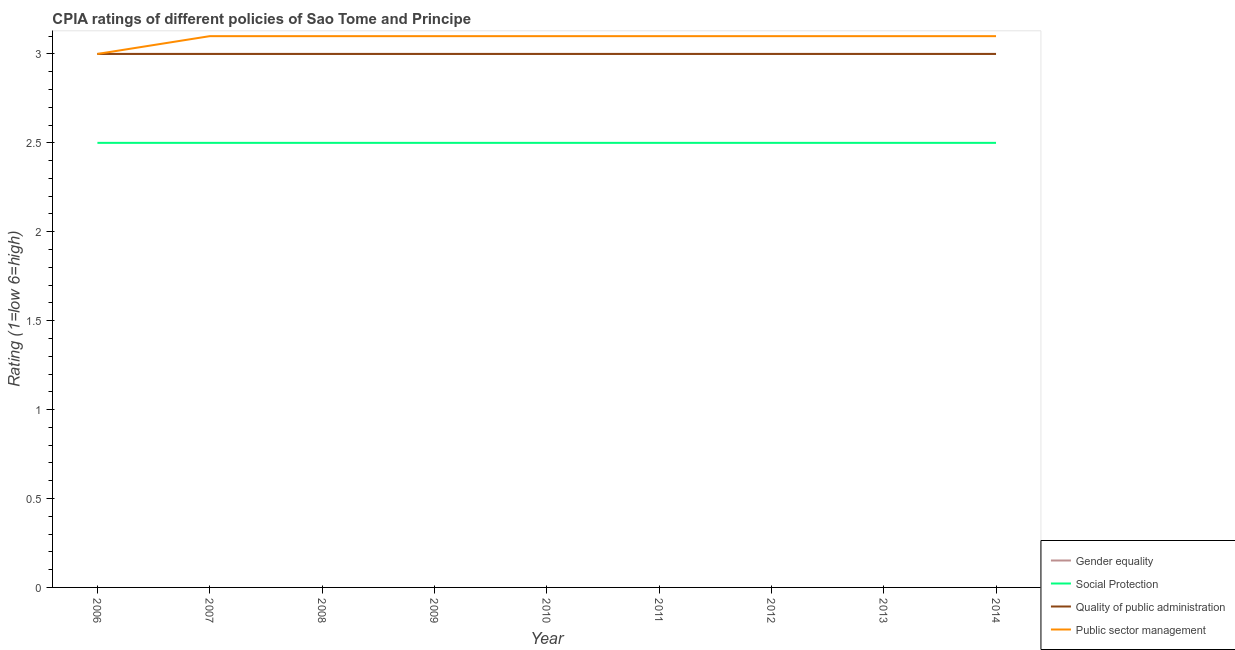How many different coloured lines are there?
Provide a succinct answer. 4. Does the line corresponding to cpia rating of quality of public administration intersect with the line corresponding to cpia rating of gender equality?
Keep it short and to the point. Yes. Is the number of lines equal to the number of legend labels?
Ensure brevity in your answer.  Yes. What is the cpia rating of gender equality in 2014?
Offer a terse response. 3. Across all years, what is the minimum cpia rating of gender equality?
Keep it short and to the point. 3. In which year was the cpia rating of gender equality maximum?
Keep it short and to the point. 2006. In which year was the cpia rating of public sector management minimum?
Offer a terse response. 2006. What is the total cpia rating of gender equality in the graph?
Keep it short and to the point. 27. What is the difference between the cpia rating of public sector management in 2009 and that in 2011?
Offer a terse response. 0. What is the difference between the cpia rating of social protection in 2014 and the cpia rating of public sector management in 2007?
Keep it short and to the point. -0.6. In the year 2012, what is the difference between the cpia rating of public sector management and cpia rating of gender equality?
Provide a succinct answer. 0.1. In how many years, is the cpia rating of social protection greater than 1.5?
Ensure brevity in your answer.  9. What is the ratio of the cpia rating of quality of public administration in 2009 to that in 2012?
Your answer should be compact. 1. What is the difference between the highest and the lowest cpia rating of social protection?
Make the answer very short. 0. In how many years, is the cpia rating of social protection greater than the average cpia rating of social protection taken over all years?
Provide a succinct answer. 0. Is the sum of the cpia rating of social protection in 2012 and 2013 greater than the maximum cpia rating of public sector management across all years?
Your answer should be compact. Yes. Is it the case that in every year, the sum of the cpia rating of gender equality and cpia rating of social protection is greater than the cpia rating of quality of public administration?
Provide a short and direct response. Yes. Is the cpia rating of gender equality strictly greater than the cpia rating of social protection over the years?
Give a very brief answer. Yes. Is the cpia rating of social protection strictly less than the cpia rating of gender equality over the years?
Provide a succinct answer. Yes. What is the difference between two consecutive major ticks on the Y-axis?
Offer a terse response. 0.5. Does the graph contain grids?
Your response must be concise. No. Where does the legend appear in the graph?
Keep it short and to the point. Bottom right. How are the legend labels stacked?
Ensure brevity in your answer.  Vertical. What is the title of the graph?
Offer a very short reply. CPIA ratings of different policies of Sao Tome and Principe. What is the Rating (1=low 6=high) of Gender equality in 2006?
Your answer should be compact. 3. What is the Rating (1=low 6=high) in Social Protection in 2006?
Your answer should be compact. 2.5. What is the Rating (1=low 6=high) in Public sector management in 2006?
Ensure brevity in your answer.  3. What is the Rating (1=low 6=high) in Public sector management in 2007?
Ensure brevity in your answer.  3.1. What is the Rating (1=low 6=high) in Gender equality in 2008?
Offer a very short reply. 3. What is the Rating (1=low 6=high) in Social Protection in 2008?
Provide a short and direct response. 2.5. What is the Rating (1=low 6=high) in Public sector management in 2008?
Your answer should be compact. 3.1. What is the Rating (1=low 6=high) of Quality of public administration in 2009?
Keep it short and to the point. 3. What is the Rating (1=low 6=high) in Public sector management in 2009?
Provide a short and direct response. 3.1. What is the Rating (1=low 6=high) in Quality of public administration in 2010?
Your response must be concise. 3. What is the Rating (1=low 6=high) of Public sector management in 2010?
Offer a very short reply. 3.1. What is the Rating (1=low 6=high) of Social Protection in 2011?
Keep it short and to the point. 2.5. What is the Rating (1=low 6=high) in Quality of public administration in 2011?
Ensure brevity in your answer.  3. What is the Rating (1=low 6=high) of Public sector management in 2011?
Give a very brief answer. 3.1. What is the Rating (1=low 6=high) of Quality of public administration in 2012?
Your answer should be compact. 3. What is the Rating (1=low 6=high) in Gender equality in 2013?
Offer a terse response. 3. What is the Rating (1=low 6=high) in Social Protection in 2013?
Your answer should be compact. 2.5. What is the Rating (1=low 6=high) of Public sector management in 2013?
Keep it short and to the point. 3.1. What is the Rating (1=low 6=high) in Gender equality in 2014?
Make the answer very short. 3. What is the Rating (1=low 6=high) in Social Protection in 2014?
Your answer should be compact. 2.5. Across all years, what is the maximum Rating (1=low 6=high) of Gender equality?
Ensure brevity in your answer.  3. Across all years, what is the minimum Rating (1=low 6=high) in Gender equality?
Ensure brevity in your answer.  3. Across all years, what is the minimum Rating (1=low 6=high) in Social Protection?
Keep it short and to the point. 2.5. Across all years, what is the minimum Rating (1=low 6=high) of Quality of public administration?
Provide a succinct answer. 3. Across all years, what is the minimum Rating (1=low 6=high) in Public sector management?
Offer a terse response. 3. What is the total Rating (1=low 6=high) of Gender equality in the graph?
Your response must be concise. 27. What is the total Rating (1=low 6=high) of Quality of public administration in the graph?
Make the answer very short. 27. What is the total Rating (1=low 6=high) of Public sector management in the graph?
Keep it short and to the point. 27.8. What is the difference between the Rating (1=low 6=high) in Social Protection in 2006 and that in 2007?
Your response must be concise. 0. What is the difference between the Rating (1=low 6=high) in Gender equality in 2006 and that in 2009?
Provide a short and direct response. 0. What is the difference between the Rating (1=low 6=high) of Social Protection in 2006 and that in 2009?
Your response must be concise. 0. What is the difference between the Rating (1=low 6=high) in Public sector management in 2006 and that in 2009?
Provide a succinct answer. -0.1. What is the difference between the Rating (1=low 6=high) in Gender equality in 2006 and that in 2010?
Offer a terse response. 0. What is the difference between the Rating (1=low 6=high) in Social Protection in 2006 and that in 2010?
Offer a terse response. 0. What is the difference between the Rating (1=low 6=high) in Quality of public administration in 2006 and that in 2010?
Provide a succinct answer. 0. What is the difference between the Rating (1=low 6=high) in Public sector management in 2006 and that in 2010?
Provide a short and direct response. -0.1. What is the difference between the Rating (1=low 6=high) of Social Protection in 2006 and that in 2011?
Keep it short and to the point. 0. What is the difference between the Rating (1=low 6=high) of Gender equality in 2006 and that in 2012?
Your response must be concise. 0. What is the difference between the Rating (1=low 6=high) in Social Protection in 2006 and that in 2012?
Ensure brevity in your answer.  0. What is the difference between the Rating (1=low 6=high) of Social Protection in 2006 and that in 2013?
Offer a terse response. 0. What is the difference between the Rating (1=low 6=high) in Quality of public administration in 2006 and that in 2013?
Give a very brief answer. 0. What is the difference between the Rating (1=low 6=high) of Social Protection in 2006 and that in 2014?
Provide a succinct answer. 0. What is the difference between the Rating (1=low 6=high) of Quality of public administration in 2006 and that in 2014?
Offer a terse response. 0. What is the difference between the Rating (1=low 6=high) in Public sector management in 2007 and that in 2008?
Your response must be concise. 0. What is the difference between the Rating (1=low 6=high) of Quality of public administration in 2007 and that in 2009?
Your answer should be compact. 0. What is the difference between the Rating (1=low 6=high) in Public sector management in 2007 and that in 2009?
Make the answer very short. 0. What is the difference between the Rating (1=low 6=high) of Quality of public administration in 2007 and that in 2010?
Ensure brevity in your answer.  0. What is the difference between the Rating (1=low 6=high) in Public sector management in 2007 and that in 2010?
Provide a succinct answer. 0. What is the difference between the Rating (1=low 6=high) in Social Protection in 2007 and that in 2011?
Provide a short and direct response. 0. What is the difference between the Rating (1=low 6=high) of Public sector management in 2007 and that in 2011?
Your response must be concise. 0. What is the difference between the Rating (1=low 6=high) in Social Protection in 2007 and that in 2012?
Offer a terse response. 0. What is the difference between the Rating (1=low 6=high) of Quality of public administration in 2007 and that in 2012?
Your answer should be compact. 0. What is the difference between the Rating (1=low 6=high) of Public sector management in 2007 and that in 2012?
Offer a very short reply. 0. What is the difference between the Rating (1=low 6=high) in Gender equality in 2007 and that in 2013?
Provide a succinct answer. 0. What is the difference between the Rating (1=low 6=high) of Social Protection in 2007 and that in 2013?
Make the answer very short. 0. What is the difference between the Rating (1=low 6=high) in Quality of public administration in 2007 and that in 2013?
Your response must be concise. 0. What is the difference between the Rating (1=low 6=high) of Gender equality in 2007 and that in 2014?
Offer a terse response. 0. What is the difference between the Rating (1=low 6=high) in Social Protection in 2007 and that in 2014?
Your answer should be very brief. 0. What is the difference between the Rating (1=low 6=high) of Public sector management in 2007 and that in 2014?
Provide a succinct answer. 0. What is the difference between the Rating (1=low 6=high) of Gender equality in 2008 and that in 2009?
Provide a short and direct response. 0. What is the difference between the Rating (1=low 6=high) of Public sector management in 2008 and that in 2009?
Provide a succinct answer. 0. What is the difference between the Rating (1=low 6=high) in Social Protection in 2008 and that in 2010?
Your answer should be compact. 0. What is the difference between the Rating (1=low 6=high) of Gender equality in 2008 and that in 2011?
Ensure brevity in your answer.  0. What is the difference between the Rating (1=low 6=high) of Social Protection in 2008 and that in 2011?
Your answer should be very brief. 0. What is the difference between the Rating (1=low 6=high) of Social Protection in 2008 and that in 2012?
Offer a very short reply. 0. What is the difference between the Rating (1=low 6=high) in Public sector management in 2008 and that in 2012?
Give a very brief answer. 0. What is the difference between the Rating (1=low 6=high) in Social Protection in 2008 and that in 2013?
Provide a short and direct response. 0. What is the difference between the Rating (1=low 6=high) of Quality of public administration in 2008 and that in 2013?
Your answer should be compact. 0. What is the difference between the Rating (1=low 6=high) of Public sector management in 2008 and that in 2013?
Give a very brief answer. 0. What is the difference between the Rating (1=low 6=high) of Public sector management in 2008 and that in 2014?
Provide a succinct answer. 0. What is the difference between the Rating (1=low 6=high) in Gender equality in 2009 and that in 2010?
Offer a very short reply. 0. What is the difference between the Rating (1=low 6=high) in Social Protection in 2009 and that in 2010?
Your answer should be very brief. 0. What is the difference between the Rating (1=low 6=high) of Public sector management in 2009 and that in 2011?
Ensure brevity in your answer.  0. What is the difference between the Rating (1=low 6=high) of Gender equality in 2009 and that in 2012?
Provide a succinct answer. 0. What is the difference between the Rating (1=low 6=high) of Public sector management in 2009 and that in 2013?
Offer a very short reply. 0. What is the difference between the Rating (1=low 6=high) in Gender equality in 2010 and that in 2011?
Your answer should be very brief. 0. What is the difference between the Rating (1=low 6=high) in Quality of public administration in 2010 and that in 2011?
Offer a very short reply. 0. What is the difference between the Rating (1=low 6=high) of Public sector management in 2010 and that in 2011?
Your response must be concise. 0. What is the difference between the Rating (1=low 6=high) in Gender equality in 2010 and that in 2012?
Your answer should be very brief. 0. What is the difference between the Rating (1=low 6=high) of Quality of public administration in 2010 and that in 2012?
Offer a terse response. 0. What is the difference between the Rating (1=low 6=high) in Public sector management in 2010 and that in 2012?
Your answer should be very brief. 0. What is the difference between the Rating (1=low 6=high) in Social Protection in 2010 and that in 2013?
Give a very brief answer. 0. What is the difference between the Rating (1=low 6=high) in Quality of public administration in 2010 and that in 2013?
Provide a succinct answer. 0. What is the difference between the Rating (1=low 6=high) in Gender equality in 2010 and that in 2014?
Your answer should be compact. 0. What is the difference between the Rating (1=low 6=high) in Quality of public administration in 2010 and that in 2014?
Give a very brief answer. 0. What is the difference between the Rating (1=low 6=high) of Public sector management in 2010 and that in 2014?
Offer a terse response. 0. What is the difference between the Rating (1=low 6=high) of Social Protection in 2011 and that in 2012?
Provide a succinct answer. 0. What is the difference between the Rating (1=low 6=high) of Gender equality in 2011 and that in 2013?
Provide a succinct answer. 0. What is the difference between the Rating (1=low 6=high) of Public sector management in 2011 and that in 2013?
Offer a terse response. 0. What is the difference between the Rating (1=low 6=high) in Social Protection in 2011 and that in 2014?
Offer a terse response. 0. What is the difference between the Rating (1=low 6=high) of Gender equality in 2012 and that in 2013?
Provide a succinct answer. 0. What is the difference between the Rating (1=low 6=high) of Social Protection in 2012 and that in 2013?
Give a very brief answer. 0. What is the difference between the Rating (1=low 6=high) of Public sector management in 2012 and that in 2013?
Provide a short and direct response. 0. What is the difference between the Rating (1=low 6=high) of Gender equality in 2012 and that in 2014?
Keep it short and to the point. 0. What is the difference between the Rating (1=low 6=high) in Public sector management in 2012 and that in 2014?
Provide a succinct answer. 0. What is the difference between the Rating (1=low 6=high) in Social Protection in 2013 and that in 2014?
Offer a very short reply. 0. What is the difference between the Rating (1=low 6=high) in Quality of public administration in 2013 and that in 2014?
Ensure brevity in your answer.  0. What is the difference between the Rating (1=low 6=high) of Gender equality in 2006 and the Rating (1=low 6=high) of Social Protection in 2007?
Offer a terse response. 0.5. What is the difference between the Rating (1=low 6=high) of Social Protection in 2006 and the Rating (1=low 6=high) of Public sector management in 2007?
Give a very brief answer. -0.6. What is the difference between the Rating (1=low 6=high) of Quality of public administration in 2006 and the Rating (1=low 6=high) of Public sector management in 2007?
Keep it short and to the point. -0.1. What is the difference between the Rating (1=low 6=high) of Gender equality in 2006 and the Rating (1=low 6=high) of Public sector management in 2008?
Your answer should be very brief. -0.1. What is the difference between the Rating (1=low 6=high) of Social Protection in 2006 and the Rating (1=low 6=high) of Public sector management in 2008?
Give a very brief answer. -0.6. What is the difference between the Rating (1=low 6=high) in Quality of public administration in 2006 and the Rating (1=low 6=high) in Public sector management in 2008?
Make the answer very short. -0.1. What is the difference between the Rating (1=low 6=high) in Gender equality in 2006 and the Rating (1=low 6=high) in Social Protection in 2009?
Your answer should be compact. 0.5. What is the difference between the Rating (1=low 6=high) of Gender equality in 2006 and the Rating (1=low 6=high) of Quality of public administration in 2009?
Provide a short and direct response. 0. What is the difference between the Rating (1=low 6=high) of Social Protection in 2006 and the Rating (1=low 6=high) of Quality of public administration in 2009?
Make the answer very short. -0.5. What is the difference between the Rating (1=low 6=high) of Gender equality in 2006 and the Rating (1=low 6=high) of Social Protection in 2010?
Give a very brief answer. 0.5. What is the difference between the Rating (1=low 6=high) of Gender equality in 2006 and the Rating (1=low 6=high) of Quality of public administration in 2010?
Keep it short and to the point. 0. What is the difference between the Rating (1=low 6=high) of Gender equality in 2006 and the Rating (1=low 6=high) of Public sector management in 2011?
Offer a very short reply. -0.1. What is the difference between the Rating (1=low 6=high) in Social Protection in 2006 and the Rating (1=low 6=high) in Quality of public administration in 2011?
Your response must be concise. -0.5. What is the difference between the Rating (1=low 6=high) in Gender equality in 2006 and the Rating (1=low 6=high) in Quality of public administration in 2012?
Keep it short and to the point. 0. What is the difference between the Rating (1=low 6=high) of Gender equality in 2006 and the Rating (1=low 6=high) of Public sector management in 2012?
Your answer should be compact. -0.1. What is the difference between the Rating (1=low 6=high) in Social Protection in 2006 and the Rating (1=low 6=high) in Quality of public administration in 2012?
Keep it short and to the point. -0.5. What is the difference between the Rating (1=low 6=high) in Gender equality in 2006 and the Rating (1=low 6=high) in Quality of public administration in 2013?
Keep it short and to the point. 0. What is the difference between the Rating (1=low 6=high) in Social Protection in 2006 and the Rating (1=low 6=high) in Quality of public administration in 2013?
Provide a short and direct response. -0.5. What is the difference between the Rating (1=low 6=high) in Gender equality in 2006 and the Rating (1=low 6=high) in Social Protection in 2014?
Keep it short and to the point. 0.5. What is the difference between the Rating (1=low 6=high) in Gender equality in 2006 and the Rating (1=low 6=high) in Quality of public administration in 2014?
Ensure brevity in your answer.  0. What is the difference between the Rating (1=low 6=high) of Gender equality in 2006 and the Rating (1=low 6=high) of Public sector management in 2014?
Offer a very short reply. -0.1. What is the difference between the Rating (1=low 6=high) of Social Protection in 2006 and the Rating (1=low 6=high) of Public sector management in 2014?
Keep it short and to the point. -0.6. What is the difference between the Rating (1=low 6=high) in Quality of public administration in 2006 and the Rating (1=low 6=high) in Public sector management in 2014?
Keep it short and to the point. -0.1. What is the difference between the Rating (1=low 6=high) in Gender equality in 2007 and the Rating (1=low 6=high) in Social Protection in 2008?
Your answer should be very brief. 0.5. What is the difference between the Rating (1=low 6=high) in Gender equality in 2007 and the Rating (1=low 6=high) in Quality of public administration in 2008?
Your answer should be compact. 0. What is the difference between the Rating (1=low 6=high) in Gender equality in 2007 and the Rating (1=low 6=high) in Public sector management in 2008?
Ensure brevity in your answer.  -0.1. What is the difference between the Rating (1=low 6=high) in Social Protection in 2007 and the Rating (1=low 6=high) in Public sector management in 2008?
Offer a very short reply. -0.6. What is the difference between the Rating (1=low 6=high) in Quality of public administration in 2007 and the Rating (1=low 6=high) in Public sector management in 2008?
Your response must be concise. -0.1. What is the difference between the Rating (1=low 6=high) in Social Protection in 2007 and the Rating (1=low 6=high) in Public sector management in 2009?
Give a very brief answer. -0.6. What is the difference between the Rating (1=low 6=high) in Gender equality in 2007 and the Rating (1=low 6=high) in Social Protection in 2010?
Your answer should be compact. 0.5. What is the difference between the Rating (1=low 6=high) of Gender equality in 2007 and the Rating (1=low 6=high) of Public sector management in 2010?
Offer a terse response. -0.1. What is the difference between the Rating (1=low 6=high) in Quality of public administration in 2007 and the Rating (1=low 6=high) in Public sector management in 2010?
Make the answer very short. -0.1. What is the difference between the Rating (1=low 6=high) of Social Protection in 2007 and the Rating (1=low 6=high) of Quality of public administration in 2011?
Keep it short and to the point. -0.5. What is the difference between the Rating (1=low 6=high) in Gender equality in 2007 and the Rating (1=low 6=high) in Public sector management in 2012?
Give a very brief answer. -0.1. What is the difference between the Rating (1=low 6=high) in Social Protection in 2007 and the Rating (1=low 6=high) in Quality of public administration in 2012?
Provide a succinct answer. -0.5. What is the difference between the Rating (1=low 6=high) of Social Protection in 2007 and the Rating (1=low 6=high) of Public sector management in 2012?
Your answer should be very brief. -0.6. What is the difference between the Rating (1=low 6=high) in Quality of public administration in 2007 and the Rating (1=low 6=high) in Public sector management in 2013?
Offer a very short reply. -0.1. What is the difference between the Rating (1=low 6=high) of Gender equality in 2007 and the Rating (1=low 6=high) of Social Protection in 2014?
Your response must be concise. 0.5. What is the difference between the Rating (1=low 6=high) in Social Protection in 2007 and the Rating (1=low 6=high) in Quality of public administration in 2014?
Offer a very short reply. -0.5. What is the difference between the Rating (1=low 6=high) in Social Protection in 2007 and the Rating (1=low 6=high) in Public sector management in 2014?
Make the answer very short. -0.6. What is the difference between the Rating (1=low 6=high) in Gender equality in 2008 and the Rating (1=low 6=high) in Social Protection in 2009?
Your response must be concise. 0.5. What is the difference between the Rating (1=low 6=high) of Gender equality in 2008 and the Rating (1=low 6=high) of Public sector management in 2009?
Your response must be concise. -0.1. What is the difference between the Rating (1=low 6=high) of Gender equality in 2008 and the Rating (1=low 6=high) of Social Protection in 2010?
Offer a terse response. 0.5. What is the difference between the Rating (1=low 6=high) in Gender equality in 2008 and the Rating (1=low 6=high) in Public sector management in 2010?
Give a very brief answer. -0.1. What is the difference between the Rating (1=low 6=high) in Social Protection in 2008 and the Rating (1=low 6=high) in Quality of public administration in 2010?
Ensure brevity in your answer.  -0.5. What is the difference between the Rating (1=low 6=high) in Social Protection in 2008 and the Rating (1=low 6=high) in Public sector management in 2010?
Give a very brief answer. -0.6. What is the difference between the Rating (1=low 6=high) of Gender equality in 2008 and the Rating (1=low 6=high) of Quality of public administration in 2011?
Make the answer very short. 0. What is the difference between the Rating (1=low 6=high) of Social Protection in 2008 and the Rating (1=low 6=high) of Quality of public administration in 2011?
Ensure brevity in your answer.  -0.5. What is the difference between the Rating (1=low 6=high) of Social Protection in 2008 and the Rating (1=low 6=high) of Public sector management in 2011?
Offer a terse response. -0.6. What is the difference between the Rating (1=low 6=high) in Quality of public administration in 2008 and the Rating (1=low 6=high) in Public sector management in 2011?
Your answer should be compact. -0.1. What is the difference between the Rating (1=low 6=high) in Gender equality in 2008 and the Rating (1=low 6=high) in Public sector management in 2012?
Your answer should be compact. -0.1. What is the difference between the Rating (1=low 6=high) in Social Protection in 2008 and the Rating (1=low 6=high) in Public sector management in 2012?
Ensure brevity in your answer.  -0.6. What is the difference between the Rating (1=low 6=high) in Quality of public administration in 2008 and the Rating (1=low 6=high) in Public sector management in 2012?
Your answer should be very brief. -0.1. What is the difference between the Rating (1=low 6=high) of Gender equality in 2008 and the Rating (1=low 6=high) of Social Protection in 2013?
Your response must be concise. 0.5. What is the difference between the Rating (1=low 6=high) in Gender equality in 2008 and the Rating (1=low 6=high) in Quality of public administration in 2013?
Offer a terse response. 0. What is the difference between the Rating (1=low 6=high) of Quality of public administration in 2008 and the Rating (1=low 6=high) of Public sector management in 2013?
Give a very brief answer. -0.1. What is the difference between the Rating (1=low 6=high) of Gender equality in 2008 and the Rating (1=low 6=high) of Social Protection in 2014?
Provide a short and direct response. 0.5. What is the difference between the Rating (1=low 6=high) in Gender equality in 2008 and the Rating (1=low 6=high) in Public sector management in 2014?
Keep it short and to the point. -0.1. What is the difference between the Rating (1=low 6=high) in Quality of public administration in 2008 and the Rating (1=low 6=high) in Public sector management in 2014?
Provide a short and direct response. -0.1. What is the difference between the Rating (1=low 6=high) in Gender equality in 2009 and the Rating (1=low 6=high) in Social Protection in 2010?
Provide a short and direct response. 0.5. What is the difference between the Rating (1=low 6=high) of Social Protection in 2009 and the Rating (1=low 6=high) of Quality of public administration in 2010?
Provide a succinct answer. -0.5. What is the difference between the Rating (1=low 6=high) in Social Protection in 2009 and the Rating (1=low 6=high) in Public sector management in 2010?
Make the answer very short. -0.6. What is the difference between the Rating (1=low 6=high) of Gender equality in 2009 and the Rating (1=low 6=high) of Quality of public administration in 2011?
Offer a terse response. 0. What is the difference between the Rating (1=low 6=high) of Gender equality in 2009 and the Rating (1=low 6=high) of Quality of public administration in 2012?
Ensure brevity in your answer.  0. What is the difference between the Rating (1=low 6=high) in Social Protection in 2009 and the Rating (1=low 6=high) in Quality of public administration in 2012?
Offer a very short reply. -0.5. What is the difference between the Rating (1=low 6=high) in Social Protection in 2009 and the Rating (1=low 6=high) in Public sector management in 2012?
Your response must be concise. -0.6. What is the difference between the Rating (1=low 6=high) of Gender equality in 2009 and the Rating (1=low 6=high) of Social Protection in 2013?
Keep it short and to the point. 0.5. What is the difference between the Rating (1=low 6=high) in Gender equality in 2009 and the Rating (1=low 6=high) in Public sector management in 2013?
Your answer should be compact. -0.1. What is the difference between the Rating (1=low 6=high) in Gender equality in 2009 and the Rating (1=low 6=high) in Social Protection in 2014?
Your answer should be very brief. 0.5. What is the difference between the Rating (1=low 6=high) of Gender equality in 2009 and the Rating (1=low 6=high) of Quality of public administration in 2014?
Provide a short and direct response. 0. What is the difference between the Rating (1=low 6=high) of Gender equality in 2009 and the Rating (1=low 6=high) of Public sector management in 2014?
Provide a short and direct response. -0.1. What is the difference between the Rating (1=low 6=high) of Social Protection in 2009 and the Rating (1=low 6=high) of Quality of public administration in 2014?
Make the answer very short. -0.5. What is the difference between the Rating (1=low 6=high) in Quality of public administration in 2009 and the Rating (1=low 6=high) in Public sector management in 2014?
Provide a short and direct response. -0.1. What is the difference between the Rating (1=low 6=high) in Gender equality in 2010 and the Rating (1=low 6=high) in Social Protection in 2011?
Provide a succinct answer. 0.5. What is the difference between the Rating (1=low 6=high) in Gender equality in 2010 and the Rating (1=low 6=high) in Quality of public administration in 2011?
Make the answer very short. 0. What is the difference between the Rating (1=low 6=high) in Gender equality in 2010 and the Rating (1=low 6=high) in Social Protection in 2012?
Make the answer very short. 0.5. What is the difference between the Rating (1=low 6=high) in Gender equality in 2010 and the Rating (1=low 6=high) in Public sector management in 2012?
Keep it short and to the point. -0.1. What is the difference between the Rating (1=low 6=high) in Gender equality in 2010 and the Rating (1=low 6=high) in Social Protection in 2013?
Make the answer very short. 0.5. What is the difference between the Rating (1=low 6=high) of Social Protection in 2010 and the Rating (1=low 6=high) of Quality of public administration in 2013?
Your response must be concise. -0.5. What is the difference between the Rating (1=low 6=high) of Social Protection in 2010 and the Rating (1=low 6=high) of Public sector management in 2013?
Your response must be concise. -0.6. What is the difference between the Rating (1=low 6=high) in Quality of public administration in 2010 and the Rating (1=low 6=high) in Public sector management in 2013?
Offer a very short reply. -0.1. What is the difference between the Rating (1=low 6=high) in Gender equality in 2010 and the Rating (1=low 6=high) in Quality of public administration in 2014?
Offer a very short reply. 0. What is the difference between the Rating (1=low 6=high) of Social Protection in 2010 and the Rating (1=low 6=high) of Quality of public administration in 2014?
Your answer should be very brief. -0.5. What is the difference between the Rating (1=low 6=high) in Quality of public administration in 2010 and the Rating (1=low 6=high) in Public sector management in 2014?
Provide a succinct answer. -0.1. What is the difference between the Rating (1=low 6=high) of Gender equality in 2011 and the Rating (1=low 6=high) of Quality of public administration in 2012?
Your answer should be very brief. 0. What is the difference between the Rating (1=low 6=high) in Quality of public administration in 2011 and the Rating (1=low 6=high) in Public sector management in 2012?
Make the answer very short. -0.1. What is the difference between the Rating (1=low 6=high) in Gender equality in 2011 and the Rating (1=low 6=high) in Quality of public administration in 2013?
Make the answer very short. 0. What is the difference between the Rating (1=low 6=high) of Gender equality in 2011 and the Rating (1=low 6=high) of Public sector management in 2013?
Offer a very short reply. -0.1. What is the difference between the Rating (1=low 6=high) of Social Protection in 2011 and the Rating (1=low 6=high) of Quality of public administration in 2013?
Give a very brief answer. -0.5. What is the difference between the Rating (1=low 6=high) in Quality of public administration in 2011 and the Rating (1=low 6=high) in Public sector management in 2013?
Give a very brief answer. -0.1. What is the difference between the Rating (1=low 6=high) in Gender equality in 2011 and the Rating (1=low 6=high) in Social Protection in 2014?
Provide a short and direct response. 0.5. What is the difference between the Rating (1=low 6=high) of Gender equality in 2011 and the Rating (1=low 6=high) of Quality of public administration in 2014?
Offer a terse response. 0. What is the difference between the Rating (1=low 6=high) of Gender equality in 2012 and the Rating (1=low 6=high) of Social Protection in 2013?
Offer a very short reply. 0.5. What is the difference between the Rating (1=low 6=high) of Gender equality in 2012 and the Rating (1=low 6=high) of Public sector management in 2013?
Provide a succinct answer. -0.1. What is the difference between the Rating (1=low 6=high) in Social Protection in 2012 and the Rating (1=low 6=high) in Public sector management in 2013?
Your answer should be compact. -0.6. What is the difference between the Rating (1=low 6=high) in Gender equality in 2012 and the Rating (1=low 6=high) in Social Protection in 2014?
Your answer should be compact. 0.5. What is the difference between the Rating (1=low 6=high) of Social Protection in 2012 and the Rating (1=low 6=high) of Public sector management in 2014?
Ensure brevity in your answer.  -0.6. What is the difference between the Rating (1=low 6=high) in Quality of public administration in 2012 and the Rating (1=low 6=high) in Public sector management in 2014?
Make the answer very short. -0.1. What is the difference between the Rating (1=low 6=high) in Social Protection in 2013 and the Rating (1=low 6=high) in Quality of public administration in 2014?
Your answer should be compact. -0.5. What is the difference between the Rating (1=low 6=high) of Social Protection in 2013 and the Rating (1=low 6=high) of Public sector management in 2014?
Provide a short and direct response. -0.6. What is the average Rating (1=low 6=high) in Gender equality per year?
Provide a short and direct response. 3. What is the average Rating (1=low 6=high) of Public sector management per year?
Offer a terse response. 3.09. In the year 2006, what is the difference between the Rating (1=low 6=high) in Gender equality and Rating (1=low 6=high) in Social Protection?
Your answer should be compact. 0.5. In the year 2006, what is the difference between the Rating (1=low 6=high) in Gender equality and Rating (1=low 6=high) in Quality of public administration?
Your response must be concise. 0. In the year 2006, what is the difference between the Rating (1=low 6=high) of Social Protection and Rating (1=low 6=high) of Quality of public administration?
Your answer should be very brief. -0.5. In the year 2006, what is the difference between the Rating (1=low 6=high) in Quality of public administration and Rating (1=low 6=high) in Public sector management?
Provide a short and direct response. 0. In the year 2007, what is the difference between the Rating (1=low 6=high) of Gender equality and Rating (1=low 6=high) of Social Protection?
Ensure brevity in your answer.  0.5. In the year 2007, what is the difference between the Rating (1=low 6=high) in Gender equality and Rating (1=low 6=high) in Quality of public administration?
Your answer should be very brief. 0. In the year 2007, what is the difference between the Rating (1=low 6=high) in Gender equality and Rating (1=low 6=high) in Public sector management?
Ensure brevity in your answer.  -0.1. In the year 2008, what is the difference between the Rating (1=low 6=high) of Gender equality and Rating (1=low 6=high) of Social Protection?
Your answer should be very brief. 0.5. In the year 2008, what is the difference between the Rating (1=low 6=high) in Gender equality and Rating (1=low 6=high) in Quality of public administration?
Your answer should be compact. 0. In the year 2008, what is the difference between the Rating (1=low 6=high) of Social Protection and Rating (1=low 6=high) of Quality of public administration?
Keep it short and to the point. -0.5. In the year 2008, what is the difference between the Rating (1=low 6=high) of Social Protection and Rating (1=low 6=high) of Public sector management?
Ensure brevity in your answer.  -0.6. In the year 2008, what is the difference between the Rating (1=low 6=high) of Quality of public administration and Rating (1=low 6=high) of Public sector management?
Your answer should be compact. -0.1. In the year 2009, what is the difference between the Rating (1=low 6=high) in Gender equality and Rating (1=low 6=high) in Public sector management?
Make the answer very short. -0.1. In the year 2009, what is the difference between the Rating (1=low 6=high) of Social Protection and Rating (1=low 6=high) of Quality of public administration?
Keep it short and to the point. -0.5. In the year 2010, what is the difference between the Rating (1=low 6=high) of Gender equality and Rating (1=low 6=high) of Quality of public administration?
Offer a very short reply. 0. In the year 2010, what is the difference between the Rating (1=low 6=high) in Gender equality and Rating (1=low 6=high) in Public sector management?
Provide a succinct answer. -0.1. In the year 2010, what is the difference between the Rating (1=low 6=high) of Social Protection and Rating (1=low 6=high) of Quality of public administration?
Your answer should be very brief. -0.5. In the year 2010, what is the difference between the Rating (1=low 6=high) of Social Protection and Rating (1=low 6=high) of Public sector management?
Keep it short and to the point. -0.6. In the year 2010, what is the difference between the Rating (1=low 6=high) of Quality of public administration and Rating (1=low 6=high) of Public sector management?
Provide a succinct answer. -0.1. In the year 2011, what is the difference between the Rating (1=low 6=high) of Gender equality and Rating (1=low 6=high) of Quality of public administration?
Ensure brevity in your answer.  0. In the year 2011, what is the difference between the Rating (1=low 6=high) of Gender equality and Rating (1=low 6=high) of Public sector management?
Your answer should be very brief. -0.1. In the year 2011, what is the difference between the Rating (1=low 6=high) in Social Protection and Rating (1=low 6=high) in Quality of public administration?
Your answer should be very brief. -0.5. In the year 2011, what is the difference between the Rating (1=low 6=high) of Quality of public administration and Rating (1=low 6=high) of Public sector management?
Provide a short and direct response. -0.1. In the year 2012, what is the difference between the Rating (1=low 6=high) of Gender equality and Rating (1=low 6=high) of Social Protection?
Provide a succinct answer. 0.5. In the year 2012, what is the difference between the Rating (1=low 6=high) in Gender equality and Rating (1=low 6=high) in Public sector management?
Your response must be concise. -0.1. In the year 2012, what is the difference between the Rating (1=low 6=high) of Quality of public administration and Rating (1=low 6=high) of Public sector management?
Your response must be concise. -0.1. In the year 2013, what is the difference between the Rating (1=low 6=high) of Gender equality and Rating (1=low 6=high) of Quality of public administration?
Offer a very short reply. 0. In the year 2013, what is the difference between the Rating (1=low 6=high) in Gender equality and Rating (1=low 6=high) in Public sector management?
Provide a succinct answer. -0.1. In the year 2013, what is the difference between the Rating (1=low 6=high) in Quality of public administration and Rating (1=low 6=high) in Public sector management?
Make the answer very short. -0.1. In the year 2014, what is the difference between the Rating (1=low 6=high) of Gender equality and Rating (1=low 6=high) of Social Protection?
Provide a short and direct response. 0.5. In the year 2014, what is the difference between the Rating (1=low 6=high) of Social Protection and Rating (1=low 6=high) of Quality of public administration?
Give a very brief answer. -0.5. What is the ratio of the Rating (1=low 6=high) in Gender equality in 2006 to that in 2007?
Offer a terse response. 1. What is the ratio of the Rating (1=low 6=high) in Quality of public administration in 2006 to that in 2007?
Provide a short and direct response. 1. What is the ratio of the Rating (1=low 6=high) of Public sector management in 2006 to that in 2007?
Offer a terse response. 0.97. What is the ratio of the Rating (1=low 6=high) in Gender equality in 2006 to that in 2008?
Give a very brief answer. 1. What is the ratio of the Rating (1=low 6=high) of Quality of public administration in 2006 to that in 2009?
Your response must be concise. 1. What is the ratio of the Rating (1=low 6=high) of Gender equality in 2006 to that in 2010?
Offer a terse response. 1. What is the ratio of the Rating (1=low 6=high) of Quality of public administration in 2006 to that in 2010?
Make the answer very short. 1. What is the ratio of the Rating (1=low 6=high) in Public sector management in 2006 to that in 2010?
Ensure brevity in your answer.  0.97. What is the ratio of the Rating (1=low 6=high) of Gender equality in 2006 to that in 2011?
Offer a very short reply. 1. What is the ratio of the Rating (1=low 6=high) in Social Protection in 2006 to that in 2011?
Keep it short and to the point. 1. What is the ratio of the Rating (1=low 6=high) in Public sector management in 2006 to that in 2011?
Keep it short and to the point. 0.97. What is the ratio of the Rating (1=low 6=high) of Social Protection in 2006 to that in 2012?
Ensure brevity in your answer.  1. What is the ratio of the Rating (1=low 6=high) of Quality of public administration in 2006 to that in 2012?
Offer a terse response. 1. What is the ratio of the Rating (1=low 6=high) of Social Protection in 2006 to that in 2013?
Ensure brevity in your answer.  1. What is the ratio of the Rating (1=low 6=high) of Public sector management in 2006 to that in 2013?
Your answer should be very brief. 0.97. What is the ratio of the Rating (1=low 6=high) in Gender equality in 2006 to that in 2014?
Your answer should be very brief. 1. What is the ratio of the Rating (1=low 6=high) in Public sector management in 2006 to that in 2014?
Make the answer very short. 0.97. What is the ratio of the Rating (1=low 6=high) of Gender equality in 2007 to that in 2008?
Your answer should be compact. 1. What is the ratio of the Rating (1=low 6=high) of Social Protection in 2007 to that in 2008?
Your response must be concise. 1. What is the ratio of the Rating (1=low 6=high) in Public sector management in 2007 to that in 2008?
Give a very brief answer. 1. What is the ratio of the Rating (1=low 6=high) of Social Protection in 2007 to that in 2009?
Make the answer very short. 1. What is the ratio of the Rating (1=low 6=high) in Public sector management in 2007 to that in 2009?
Your response must be concise. 1. What is the ratio of the Rating (1=low 6=high) in Gender equality in 2007 to that in 2010?
Your response must be concise. 1. What is the ratio of the Rating (1=low 6=high) in Social Protection in 2007 to that in 2010?
Provide a short and direct response. 1. What is the ratio of the Rating (1=low 6=high) of Gender equality in 2007 to that in 2012?
Your answer should be compact. 1. What is the ratio of the Rating (1=low 6=high) of Gender equality in 2007 to that in 2013?
Your answer should be very brief. 1. What is the ratio of the Rating (1=low 6=high) of Social Protection in 2007 to that in 2013?
Your answer should be compact. 1. What is the ratio of the Rating (1=low 6=high) in Gender equality in 2008 to that in 2010?
Make the answer very short. 1. What is the ratio of the Rating (1=low 6=high) in Gender equality in 2008 to that in 2011?
Keep it short and to the point. 1. What is the ratio of the Rating (1=low 6=high) of Quality of public administration in 2008 to that in 2011?
Provide a short and direct response. 1. What is the ratio of the Rating (1=low 6=high) of Public sector management in 2008 to that in 2011?
Offer a very short reply. 1. What is the ratio of the Rating (1=low 6=high) of Gender equality in 2008 to that in 2012?
Your answer should be very brief. 1. What is the ratio of the Rating (1=low 6=high) in Public sector management in 2008 to that in 2012?
Offer a very short reply. 1. What is the ratio of the Rating (1=low 6=high) in Gender equality in 2008 to that in 2013?
Offer a very short reply. 1. What is the ratio of the Rating (1=low 6=high) in Social Protection in 2008 to that in 2013?
Your response must be concise. 1. What is the ratio of the Rating (1=low 6=high) of Quality of public administration in 2008 to that in 2013?
Your answer should be compact. 1. What is the ratio of the Rating (1=low 6=high) of Public sector management in 2008 to that in 2013?
Your answer should be compact. 1. What is the ratio of the Rating (1=low 6=high) in Gender equality in 2008 to that in 2014?
Your response must be concise. 1. What is the ratio of the Rating (1=low 6=high) in Social Protection in 2008 to that in 2014?
Your answer should be compact. 1. What is the ratio of the Rating (1=low 6=high) of Quality of public administration in 2008 to that in 2014?
Keep it short and to the point. 1. What is the ratio of the Rating (1=low 6=high) in Public sector management in 2008 to that in 2014?
Provide a short and direct response. 1. What is the ratio of the Rating (1=low 6=high) in Social Protection in 2009 to that in 2010?
Ensure brevity in your answer.  1. What is the ratio of the Rating (1=low 6=high) in Quality of public administration in 2009 to that in 2010?
Your response must be concise. 1. What is the ratio of the Rating (1=low 6=high) of Gender equality in 2009 to that in 2011?
Provide a short and direct response. 1. What is the ratio of the Rating (1=low 6=high) of Public sector management in 2009 to that in 2011?
Provide a succinct answer. 1. What is the ratio of the Rating (1=low 6=high) of Social Protection in 2009 to that in 2012?
Your answer should be compact. 1. What is the ratio of the Rating (1=low 6=high) in Public sector management in 2009 to that in 2012?
Keep it short and to the point. 1. What is the ratio of the Rating (1=low 6=high) in Gender equality in 2009 to that in 2013?
Keep it short and to the point. 1. What is the ratio of the Rating (1=low 6=high) in Social Protection in 2009 to that in 2013?
Offer a very short reply. 1. What is the ratio of the Rating (1=low 6=high) in Gender equality in 2009 to that in 2014?
Keep it short and to the point. 1. What is the ratio of the Rating (1=low 6=high) of Social Protection in 2010 to that in 2011?
Give a very brief answer. 1. What is the ratio of the Rating (1=low 6=high) of Public sector management in 2010 to that in 2011?
Ensure brevity in your answer.  1. What is the ratio of the Rating (1=low 6=high) in Gender equality in 2010 to that in 2012?
Make the answer very short. 1. What is the ratio of the Rating (1=low 6=high) in Public sector management in 2010 to that in 2012?
Make the answer very short. 1. What is the ratio of the Rating (1=low 6=high) of Quality of public administration in 2010 to that in 2013?
Offer a terse response. 1. What is the ratio of the Rating (1=low 6=high) of Public sector management in 2010 to that in 2013?
Give a very brief answer. 1. What is the ratio of the Rating (1=low 6=high) of Social Protection in 2010 to that in 2014?
Your answer should be compact. 1. What is the ratio of the Rating (1=low 6=high) in Public sector management in 2010 to that in 2014?
Your answer should be compact. 1. What is the ratio of the Rating (1=low 6=high) of Social Protection in 2011 to that in 2013?
Give a very brief answer. 1. What is the ratio of the Rating (1=low 6=high) in Quality of public administration in 2011 to that in 2013?
Provide a succinct answer. 1. What is the ratio of the Rating (1=low 6=high) in Public sector management in 2011 to that in 2013?
Provide a short and direct response. 1. What is the ratio of the Rating (1=low 6=high) in Social Protection in 2011 to that in 2014?
Provide a short and direct response. 1. What is the ratio of the Rating (1=low 6=high) of Quality of public administration in 2011 to that in 2014?
Offer a terse response. 1. What is the ratio of the Rating (1=low 6=high) of Public sector management in 2011 to that in 2014?
Provide a short and direct response. 1. What is the ratio of the Rating (1=low 6=high) of Social Protection in 2012 to that in 2013?
Your answer should be compact. 1. What is the ratio of the Rating (1=low 6=high) in Social Protection in 2012 to that in 2014?
Give a very brief answer. 1. What is the ratio of the Rating (1=low 6=high) of Quality of public administration in 2012 to that in 2014?
Keep it short and to the point. 1. What is the ratio of the Rating (1=low 6=high) of Gender equality in 2013 to that in 2014?
Give a very brief answer. 1. What is the difference between the highest and the second highest Rating (1=low 6=high) of Gender equality?
Ensure brevity in your answer.  0. What is the difference between the highest and the lowest Rating (1=low 6=high) in Gender equality?
Offer a terse response. 0. What is the difference between the highest and the lowest Rating (1=low 6=high) of Social Protection?
Make the answer very short. 0. What is the difference between the highest and the lowest Rating (1=low 6=high) in Quality of public administration?
Offer a terse response. 0. What is the difference between the highest and the lowest Rating (1=low 6=high) of Public sector management?
Offer a very short reply. 0.1. 